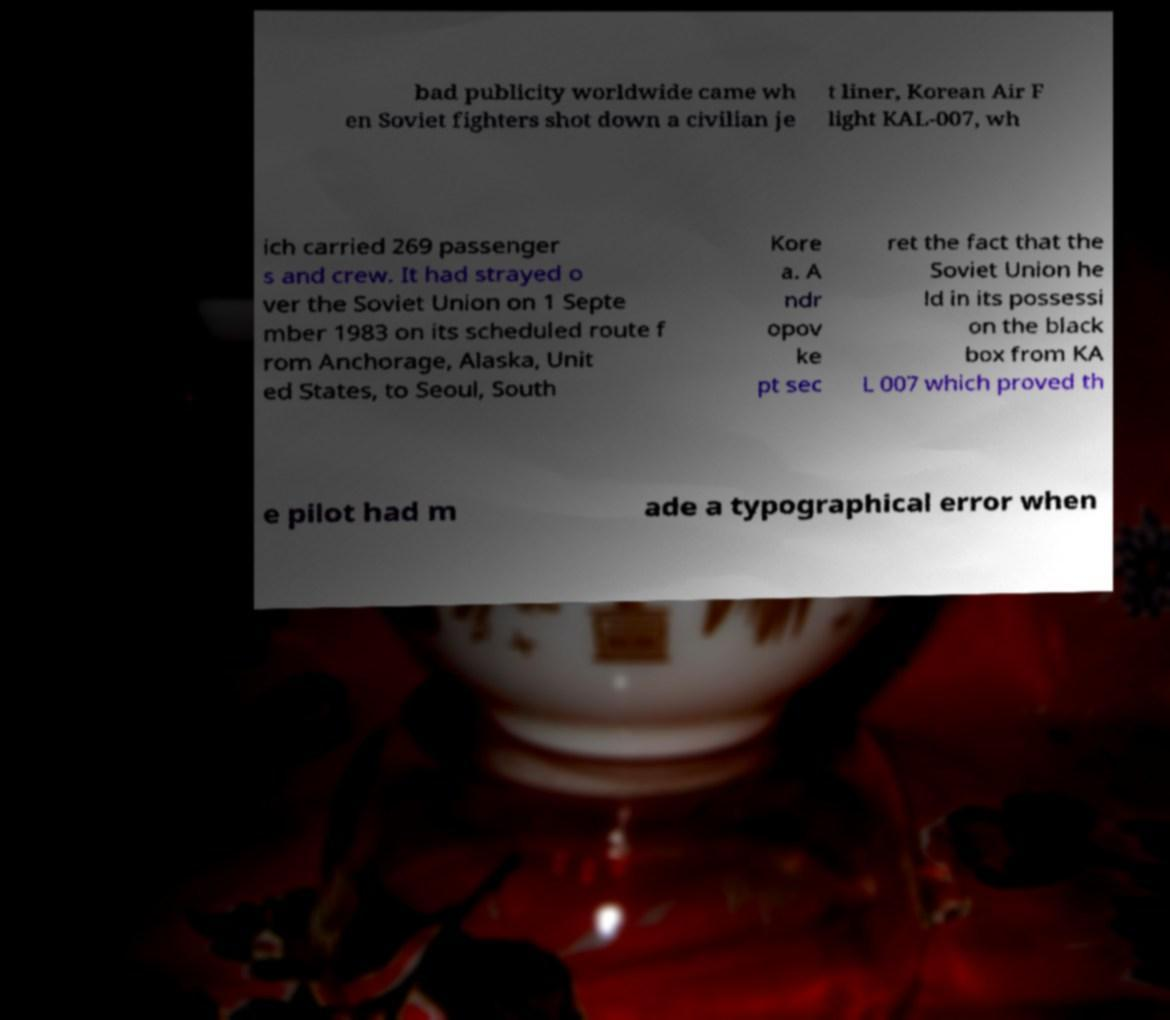Please read and relay the text visible in this image. What does it say? bad publicity worldwide came wh en Soviet fighters shot down a civilian je t liner, Korean Air F light KAL-007, wh ich carried 269 passenger s and crew. It had strayed o ver the Soviet Union on 1 Septe mber 1983 on its scheduled route f rom Anchorage, Alaska, Unit ed States, to Seoul, South Kore a. A ndr opov ke pt sec ret the fact that the Soviet Union he ld in its possessi on the black box from KA L 007 which proved th e pilot had m ade a typographical error when 